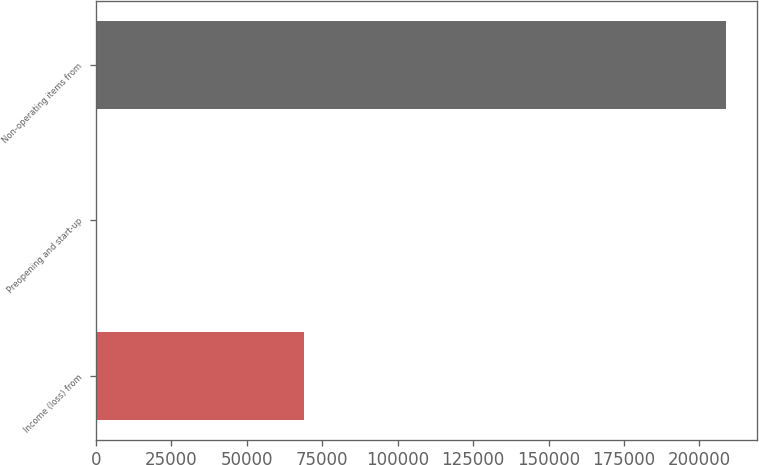<chart> <loc_0><loc_0><loc_500><loc_500><bar_chart><fcel>Income (loss) from<fcel>Preopening and start-up<fcel>Non-operating items from<nl><fcel>68829<fcel>507<fcel>208682<nl></chart> 